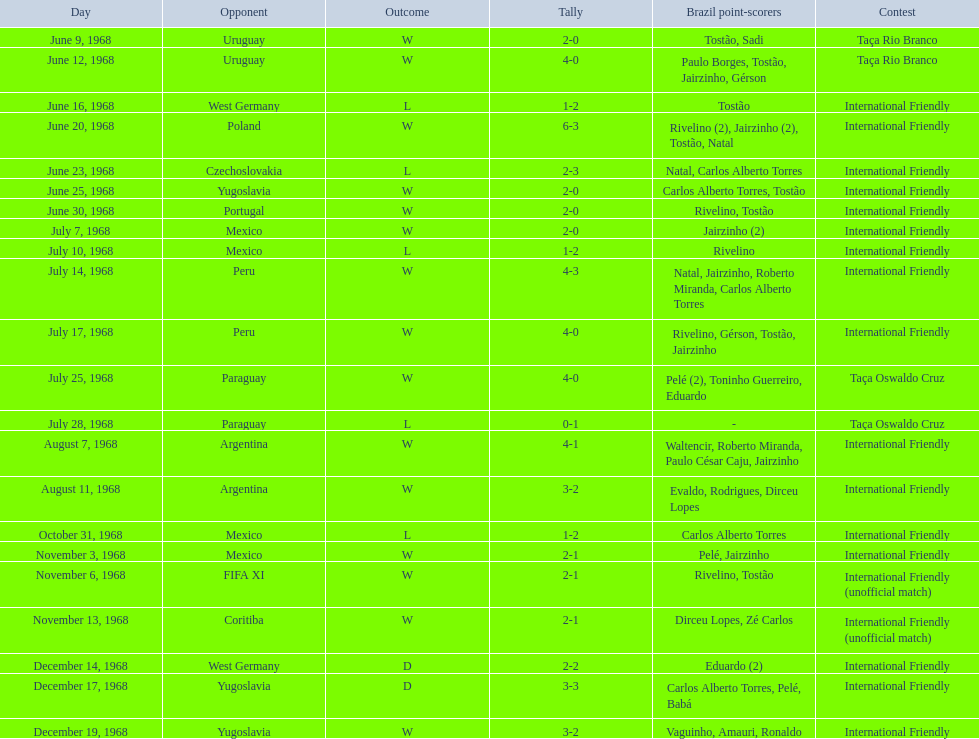What is the top score ever scored by the brazil national team? 6. Could you parse the entire table as a dict? {'header': ['Day', 'Opponent', 'Outcome', 'Tally', 'Brazil point-scorers', 'Contest'], 'rows': [['June 9, 1968', 'Uruguay', 'W', '2-0', 'Tostão, Sadi', 'Taça Rio Branco'], ['June 12, 1968', 'Uruguay', 'W', '4-0', 'Paulo Borges, Tostão, Jairzinho, Gérson', 'Taça Rio Branco'], ['June 16, 1968', 'West Germany', 'L', '1-2', 'Tostão', 'International Friendly'], ['June 20, 1968', 'Poland', 'W', '6-3', 'Rivelino (2), Jairzinho (2), Tostão, Natal', 'International Friendly'], ['June 23, 1968', 'Czechoslovakia', 'L', '2-3', 'Natal, Carlos Alberto Torres', 'International Friendly'], ['June 25, 1968', 'Yugoslavia', 'W', '2-0', 'Carlos Alberto Torres, Tostão', 'International Friendly'], ['June 30, 1968', 'Portugal', 'W', '2-0', 'Rivelino, Tostão', 'International Friendly'], ['July 7, 1968', 'Mexico', 'W', '2-0', 'Jairzinho (2)', 'International Friendly'], ['July 10, 1968', 'Mexico', 'L', '1-2', 'Rivelino', 'International Friendly'], ['July 14, 1968', 'Peru', 'W', '4-3', 'Natal, Jairzinho, Roberto Miranda, Carlos Alberto Torres', 'International Friendly'], ['July 17, 1968', 'Peru', 'W', '4-0', 'Rivelino, Gérson, Tostão, Jairzinho', 'International Friendly'], ['July 25, 1968', 'Paraguay', 'W', '4-0', 'Pelé (2), Toninho Guerreiro, Eduardo', 'Taça Oswaldo Cruz'], ['July 28, 1968', 'Paraguay', 'L', '0-1', '-', 'Taça Oswaldo Cruz'], ['August 7, 1968', 'Argentina', 'W', '4-1', 'Waltencir, Roberto Miranda, Paulo César Caju, Jairzinho', 'International Friendly'], ['August 11, 1968', 'Argentina', 'W', '3-2', 'Evaldo, Rodrigues, Dirceu Lopes', 'International Friendly'], ['October 31, 1968', 'Mexico', 'L', '1-2', 'Carlos Alberto Torres', 'International Friendly'], ['November 3, 1968', 'Mexico', 'W', '2-1', 'Pelé, Jairzinho', 'International Friendly'], ['November 6, 1968', 'FIFA XI', 'W', '2-1', 'Rivelino, Tostão', 'International Friendly (unofficial match)'], ['November 13, 1968', 'Coritiba', 'W', '2-1', 'Dirceu Lopes, Zé Carlos', 'International Friendly (unofficial match)'], ['December 14, 1968', 'West Germany', 'D', '2-2', 'Eduardo (2)', 'International Friendly'], ['December 17, 1968', 'Yugoslavia', 'D', '3-3', 'Carlos Alberto Torres, Pelé, Babá', 'International Friendly'], ['December 19, 1968', 'Yugoslavia', 'W', '3-2', 'Vaguinho, Amauri, Ronaldo', 'International Friendly']]} 